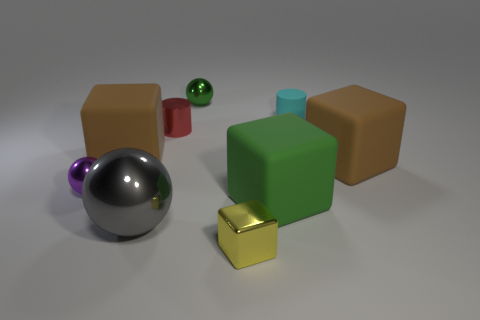If lighting in the scene changed, how might that affect the objects' appearance? Variable lighting scenarios could dramatically change our perception of the objects. Increased brightness might intensify reflections and highlights, particularly on the shiny spheres and on the edges of the cubes. If the light source were colored, it could cast hues onto the surfaces, altering their apparent colors. Shadows would shift and change in length and sharpness with the light's direction, potentially revealing more about the objects' shapes and creating a different mood within the scene. Which object appears to be in the foreground based on the perspective? The gray sphere is positioned at the front and is the most prominent object due to its placement and size relative to the other objects. It obscures part of the green cube and the small golden cube, contributing to the depth of the scene. 